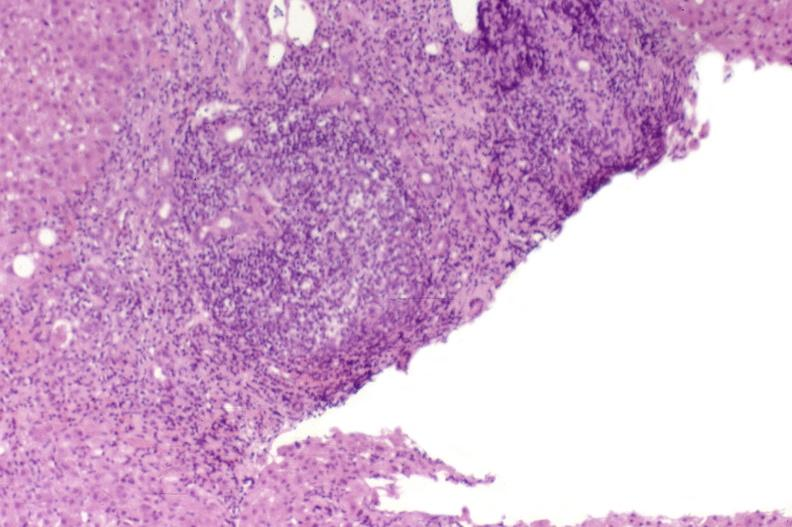s hepatobiliary present?
Answer the question using a single word or phrase. Yes 